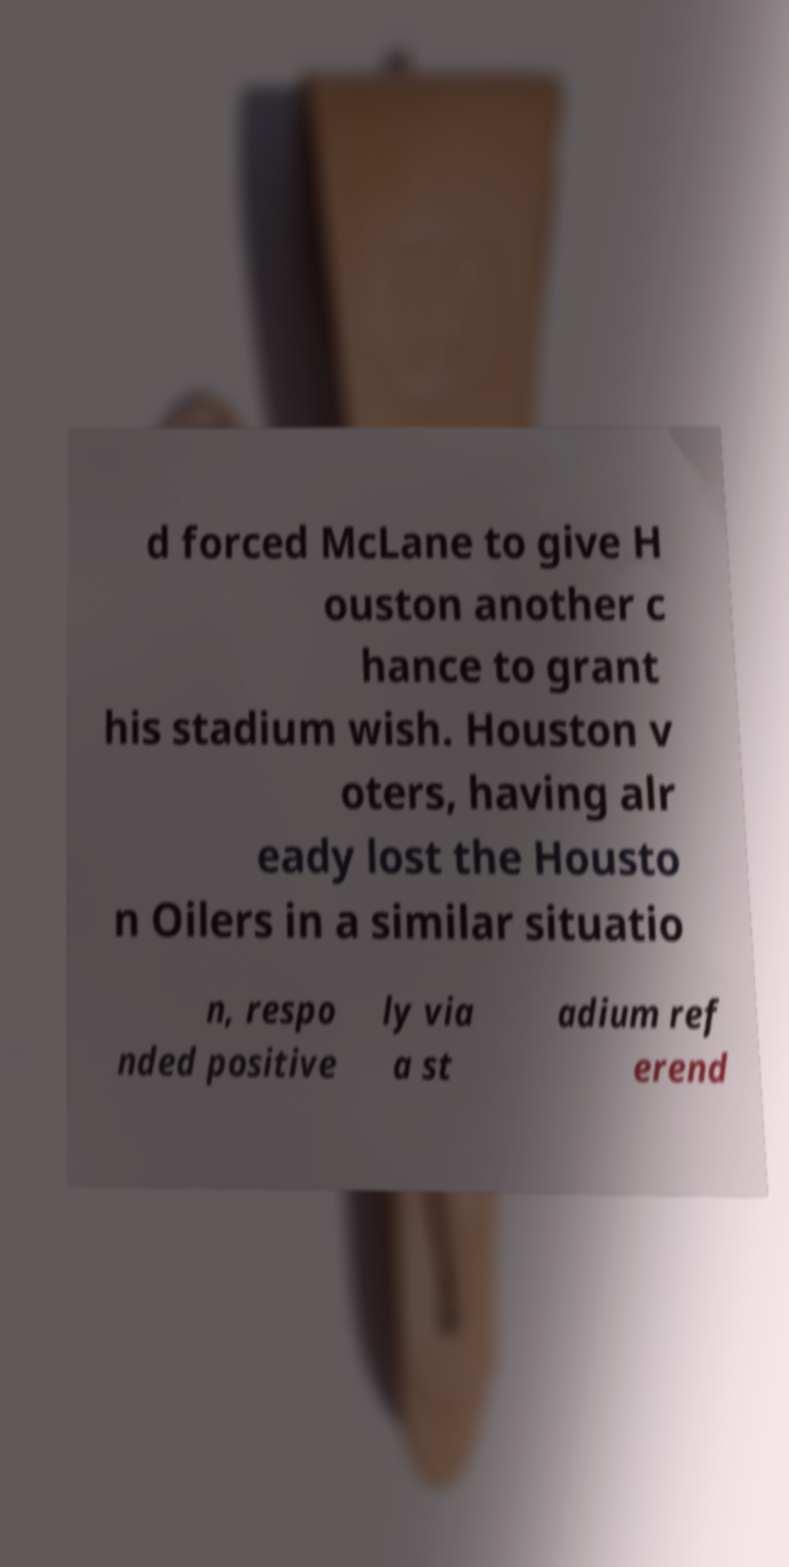Could you extract and type out the text from this image? d forced McLane to give H ouston another c hance to grant his stadium wish. Houston v oters, having alr eady lost the Housto n Oilers in a similar situatio n, respo nded positive ly via a st adium ref erend 